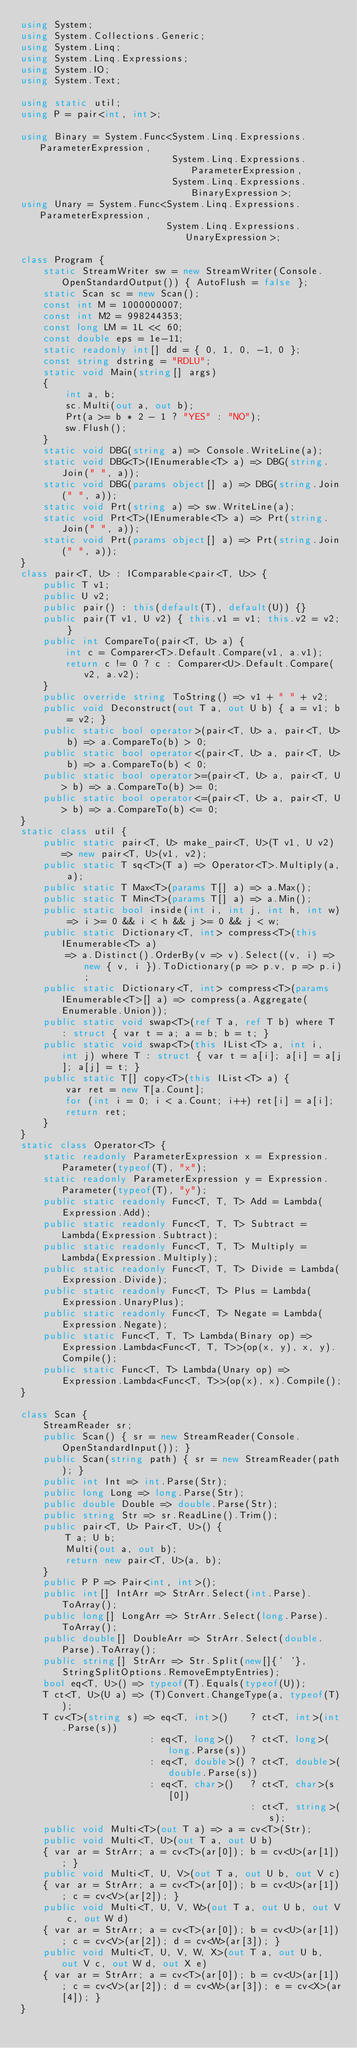<code> <loc_0><loc_0><loc_500><loc_500><_C#_>using System;
using System.Collections.Generic;
using System.Linq;
using System.Linq.Expressions;
using System.IO;
using System.Text;

using static util;
using P = pair<int, int>;

using Binary = System.Func<System.Linq.Expressions.ParameterExpression,
                           System.Linq.Expressions.ParameterExpression,
                           System.Linq.Expressions.BinaryExpression>;
using Unary = System.Func<System.Linq.Expressions.ParameterExpression,
                          System.Linq.Expressions.UnaryExpression>;

class Program {
    static StreamWriter sw = new StreamWriter(Console.OpenStandardOutput()) { AutoFlush = false };
    static Scan sc = new Scan();
    const int M = 1000000007;
    const int M2 = 998244353;
    const long LM = 1L << 60;
    const double eps = 1e-11;
    static readonly int[] dd = { 0, 1, 0, -1, 0 };
    const string dstring = "RDLU";
    static void Main(string[] args)
    {
        int a, b;
        sc.Multi(out a, out b);
        Prt(a >= b * 2 - 1 ? "YES" : "NO");
        sw.Flush();
    }
    static void DBG(string a) => Console.WriteLine(a);
    static void DBG<T>(IEnumerable<T> a) => DBG(string.Join(" ", a));
    static void DBG(params object[] a) => DBG(string.Join(" ", a));
    static void Prt(string a) => sw.WriteLine(a);
    static void Prt<T>(IEnumerable<T> a) => Prt(string.Join(" ", a));
    static void Prt(params object[] a) => Prt(string.Join(" ", a));
}
class pair<T, U> : IComparable<pair<T, U>> {
    public T v1;
    public U v2;
    public pair() : this(default(T), default(U)) {}
    public pair(T v1, U v2) { this.v1 = v1; this.v2 = v2; }
    public int CompareTo(pair<T, U> a) {
        int c = Comparer<T>.Default.Compare(v1, a.v1);
        return c != 0 ? c : Comparer<U>.Default.Compare(v2, a.v2);
    }
    public override string ToString() => v1 + " " + v2;
    public void Deconstruct(out T a, out U b) { a = v1; b = v2; }
    public static bool operator>(pair<T, U> a, pair<T, U> b) => a.CompareTo(b) > 0;
    public static bool operator<(pair<T, U> a, pair<T, U> b) => a.CompareTo(b) < 0;
    public static bool operator>=(pair<T, U> a, pair<T, U> b) => a.CompareTo(b) >= 0;
    public static bool operator<=(pair<T, U> a, pair<T, U> b) => a.CompareTo(b) <= 0;
}
static class util {
    public static pair<T, U> make_pair<T, U>(T v1, U v2) => new pair<T, U>(v1, v2);
    public static T sq<T>(T a) => Operator<T>.Multiply(a, a);
    public static T Max<T>(params T[] a) => a.Max();
    public static T Min<T>(params T[] a) => a.Min();
    public static bool inside(int i, int j, int h, int w) => i >= 0 && i < h && j >= 0 && j < w;
    public static Dictionary<T, int> compress<T>(this IEnumerable<T> a)
        => a.Distinct().OrderBy(v => v).Select((v, i) => new { v, i }).ToDictionary(p => p.v, p => p.i);
    public static Dictionary<T, int> compress<T>(params IEnumerable<T>[] a) => compress(a.Aggregate(Enumerable.Union));
    public static void swap<T>(ref T a, ref T b) where T : struct { var t = a; a = b; b = t; }
    public static void swap<T>(this IList<T> a, int i, int j) where T : struct { var t = a[i]; a[i] = a[j]; a[j] = t; }
    public static T[] copy<T>(this IList<T> a) {
        var ret = new T[a.Count];
        for (int i = 0; i < a.Count; i++) ret[i] = a[i];
        return ret;
    }
}
static class Operator<T> {
    static readonly ParameterExpression x = Expression.Parameter(typeof(T), "x");
    static readonly ParameterExpression y = Expression.Parameter(typeof(T), "y");
    public static readonly Func<T, T, T> Add = Lambda(Expression.Add);
    public static readonly Func<T, T, T> Subtract = Lambda(Expression.Subtract);
    public static readonly Func<T, T, T> Multiply = Lambda(Expression.Multiply);
    public static readonly Func<T, T, T> Divide = Lambda(Expression.Divide);
    public static readonly Func<T, T> Plus = Lambda(Expression.UnaryPlus);
    public static readonly Func<T, T> Negate = Lambda(Expression.Negate);
    public static Func<T, T, T> Lambda(Binary op) => Expression.Lambda<Func<T, T, T>>(op(x, y), x, y).Compile();
    public static Func<T, T> Lambda(Unary op) => Expression.Lambda<Func<T, T>>(op(x), x).Compile();
}

class Scan {
    StreamReader sr;
    public Scan() { sr = new StreamReader(Console.OpenStandardInput()); }
    public Scan(string path) { sr = new StreamReader(path); }
    public int Int => int.Parse(Str);
    public long Long => long.Parse(Str);
    public double Double => double.Parse(Str);
    public string Str => sr.ReadLine().Trim();
    public pair<T, U> Pair<T, U>() {
        T a; U b;
        Multi(out a, out b);
        return new pair<T, U>(a, b);
    }
    public P P => Pair<int, int>();
    public int[] IntArr => StrArr.Select(int.Parse).ToArray();
    public long[] LongArr => StrArr.Select(long.Parse).ToArray();
    public double[] DoubleArr => StrArr.Select(double.Parse).ToArray();
    public string[] StrArr => Str.Split(new[]{' '}, StringSplitOptions.RemoveEmptyEntries);
    bool eq<T, U>() => typeof(T).Equals(typeof(U));
    T ct<T, U>(U a) => (T)Convert.ChangeType(a, typeof(T));
    T cv<T>(string s) => eq<T, int>()    ? ct<T, int>(int.Parse(s))
                       : eq<T, long>()   ? ct<T, long>(long.Parse(s))
                       : eq<T, double>() ? ct<T, double>(double.Parse(s))
                       : eq<T, char>()   ? ct<T, char>(s[0])
                                         : ct<T, string>(s);
    public void Multi<T>(out T a) => a = cv<T>(Str);
    public void Multi<T, U>(out T a, out U b)
    { var ar = StrArr; a = cv<T>(ar[0]); b = cv<U>(ar[1]); }
    public void Multi<T, U, V>(out T a, out U b, out V c)
    { var ar = StrArr; a = cv<T>(ar[0]); b = cv<U>(ar[1]); c = cv<V>(ar[2]); }
    public void Multi<T, U, V, W>(out T a, out U b, out V c, out W d)
    { var ar = StrArr; a = cv<T>(ar[0]); b = cv<U>(ar[1]); c = cv<V>(ar[2]); d = cv<W>(ar[3]); }
    public void Multi<T, U, V, W, X>(out T a, out U b, out V c, out W d, out X e)
    { var ar = StrArr; a = cv<T>(ar[0]); b = cv<U>(ar[1]); c = cv<V>(ar[2]); d = cv<W>(ar[3]); e = cv<X>(ar[4]); }
}
</code> 